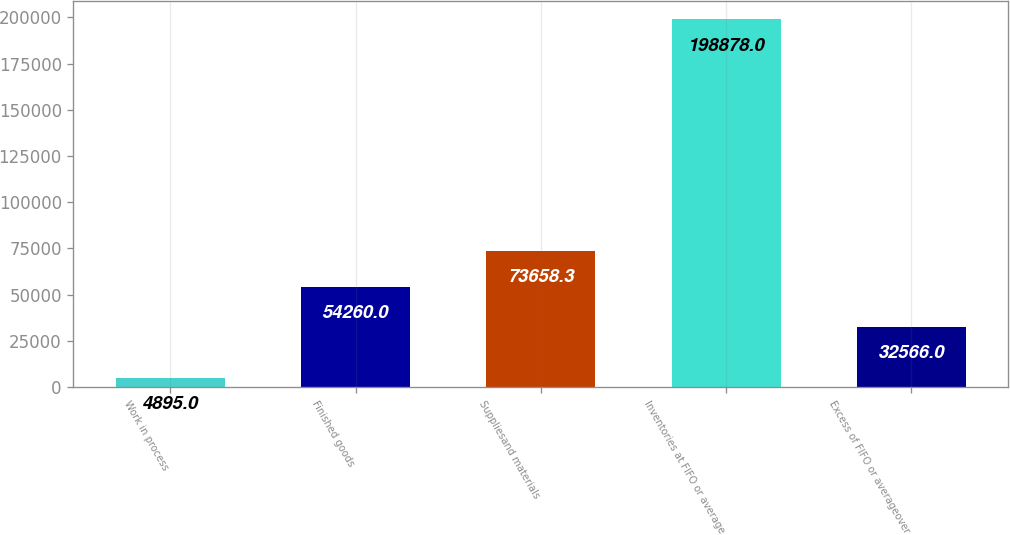Convert chart. <chart><loc_0><loc_0><loc_500><loc_500><bar_chart><fcel>Work in process<fcel>Finished goods<fcel>Suppliesand materials<fcel>Inventories at FIFO or average<fcel>Excess of FIFO or averageover<nl><fcel>4895<fcel>54260<fcel>73658.3<fcel>198878<fcel>32566<nl></chart> 